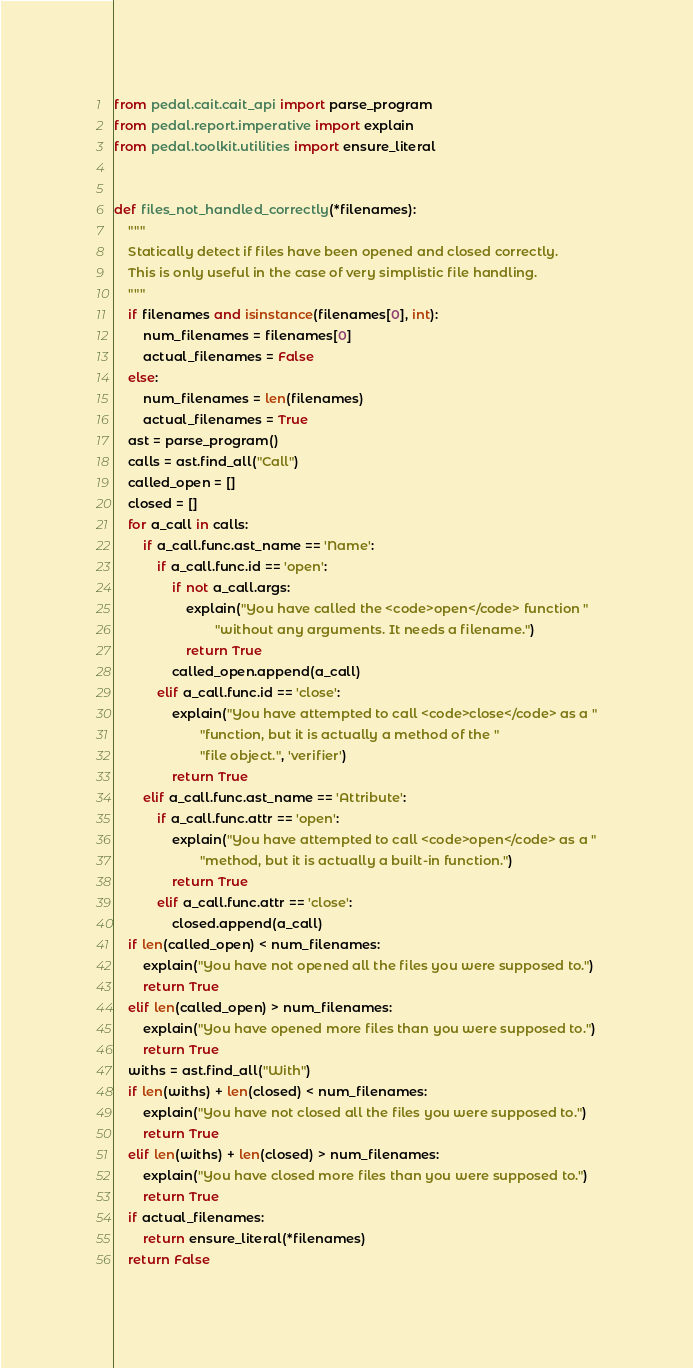Convert code to text. <code><loc_0><loc_0><loc_500><loc_500><_Python_>from pedal.cait.cait_api import parse_program
from pedal.report.imperative import explain
from pedal.toolkit.utilities import ensure_literal


def files_not_handled_correctly(*filenames):
    """
    Statically detect if files have been opened and closed correctly.
    This is only useful in the case of very simplistic file handling.
    """
    if filenames and isinstance(filenames[0], int):
        num_filenames = filenames[0]
        actual_filenames = False
    else:
        num_filenames = len(filenames)
        actual_filenames = True
    ast = parse_program()
    calls = ast.find_all("Call")
    called_open = []
    closed = []
    for a_call in calls:
        if a_call.func.ast_name == 'Name':
            if a_call.func.id == 'open':
                if not a_call.args:
                    explain("You have called the <code>open</code> function "
                            "without any arguments. It needs a filename.")
                    return True
                called_open.append(a_call)
            elif a_call.func.id == 'close':
                explain("You have attempted to call <code>close</code> as a "
                        "function, but it is actually a method of the "
                        "file object.", 'verifier')
                return True
        elif a_call.func.ast_name == 'Attribute':
            if a_call.func.attr == 'open':
                explain("You have attempted to call <code>open</code> as a "
                        "method, but it is actually a built-in function.")
                return True
            elif a_call.func.attr == 'close':
                closed.append(a_call)
    if len(called_open) < num_filenames:
        explain("You have not opened all the files you were supposed to.")
        return True
    elif len(called_open) > num_filenames:
        explain("You have opened more files than you were supposed to.")
        return True
    withs = ast.find_all("With")
    if len(withs) + len(closed) < num_filenames:
        explain("You have not closed all the files you were supposed to.")
        return True
    elif len(withs) + len(closed) > num_filenames:
        explain("You have closed more files than you were supposed to.")
        return True
    if actual_filenames:
        return ensure_literal(*filenames)
    return False
</code> 